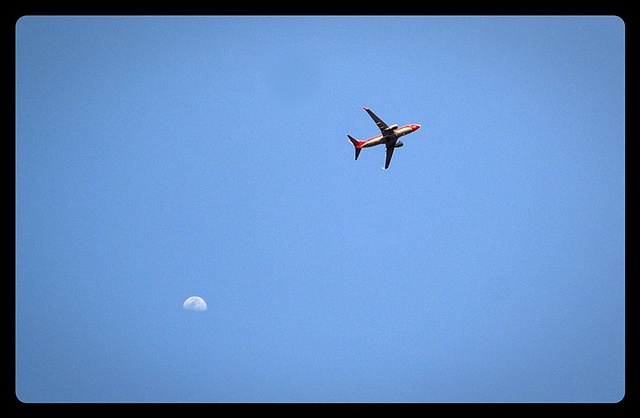Describe the objects in this image and their specific colors. I can see a airplane in black, white, gray, and darkgray tones in this image. 